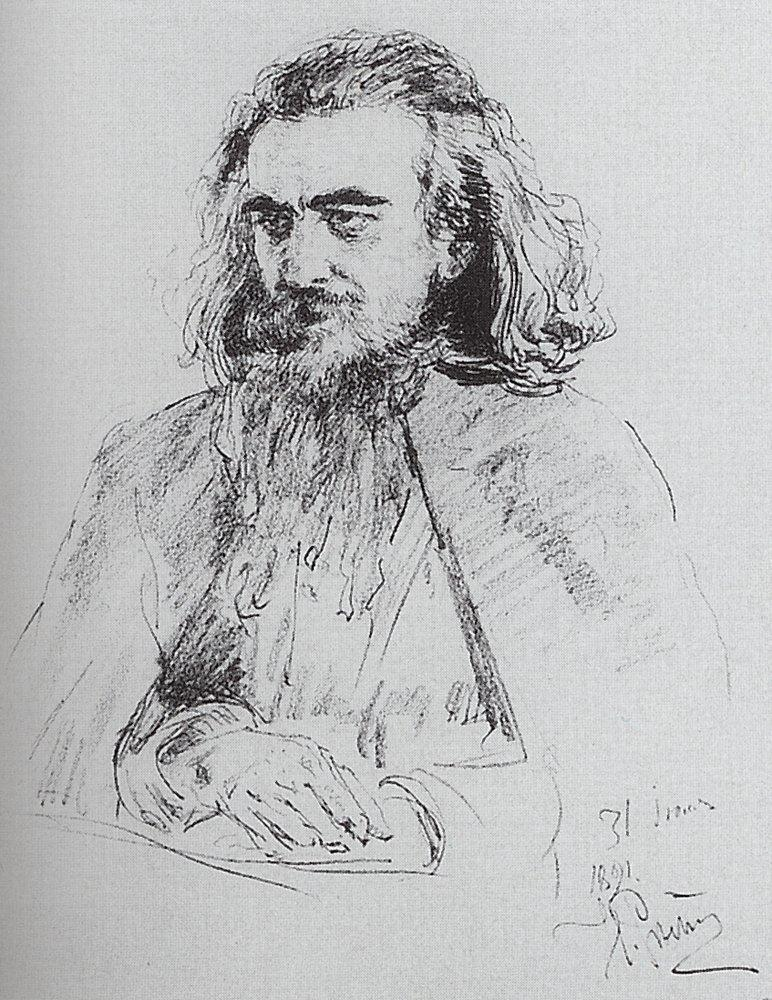Describe the following image. This image is a finely detailed black and white sketch portraying a deeply contemplative man with a long beard and flowing hair. The man appears seated, lost in thought, and the sketch captures his pensive expression with remarkable precision. Rendered in a loose yet expressive style, the artist's skillful use of lines and shading creates depth and a lifelike quality, particularly in the man's facial features and hands. The sketch is signed and dated '31 lines 1891 A. Muhlig,' indicating it was created by the artist A. Muhlig in 1891. The monochromatic palette and textured strokes evoke a timeless elegance, while the overall composition exudes a serene introspection. This portrait, focused on depicting the man's appearance and inner world, invites viewers to ponder the thoughts and emotions of the subject, making it a captivating piece of art. 